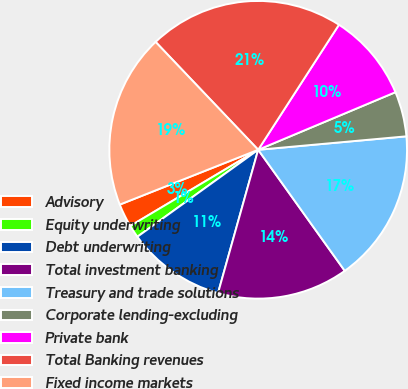<chart> <loc_0><loc_0><loc_500><loc_500><pie_chart><fcel>Advisory<fcel>Equity underwriting<fcel>Debt underwriting<fcel>Total investment banking<fcel>Treasury and trade solutions<fcel>Corporate lending-excluding<fcel>Private bank<fcel>Total Banking revenues<fcel>Fixed income markets<nl><fcel>2.55%<fcel>1.38%<fcel>10.72%<fcel>14.23%<fcel>16.56%<fcel>4.88%<fcel>9.55%<fcel>21.23%<fcel>18.9%<nl></chart> 